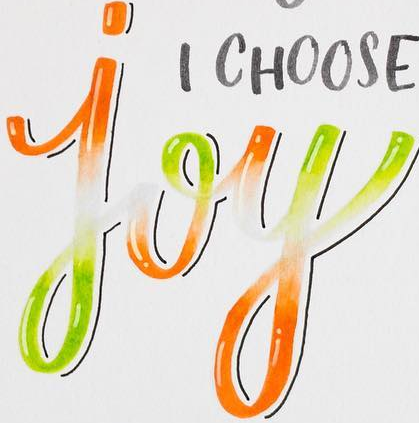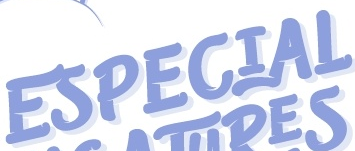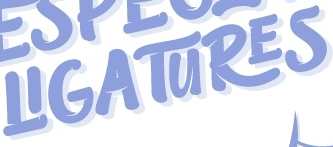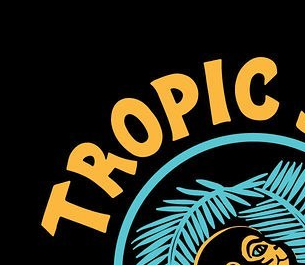What text is displayed in these images sequentially, separated by a semicolon? joy; ESPECIAL; LIGATURES; TROPLC 